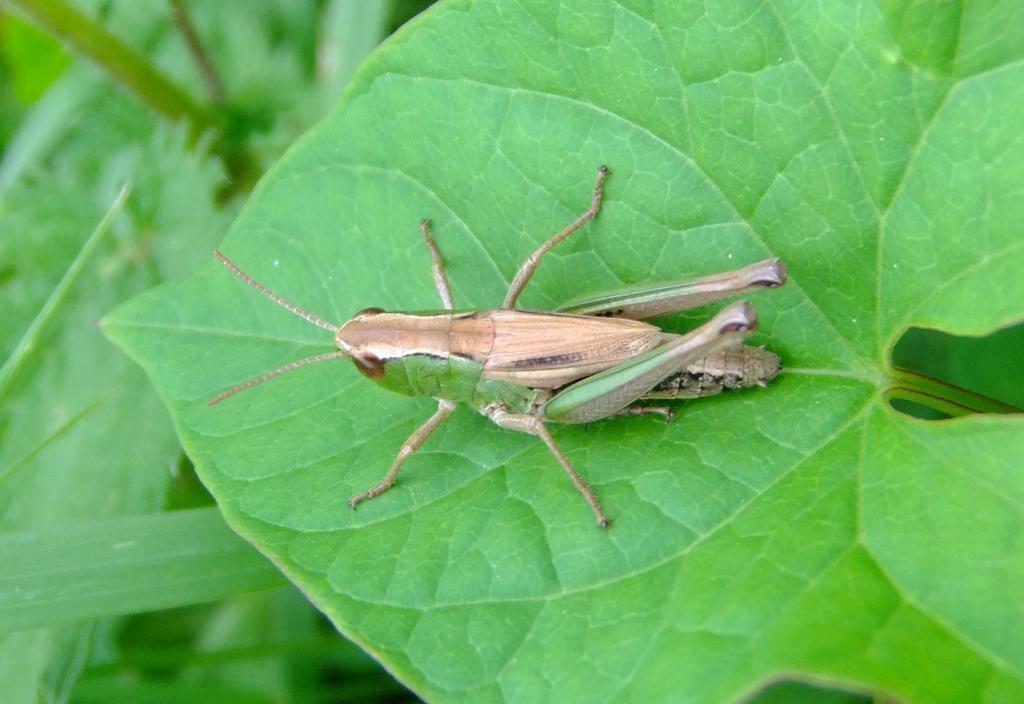In one or two sentences, can you explain what this image depicts? As we can see in the image there are leaves and an insect. 